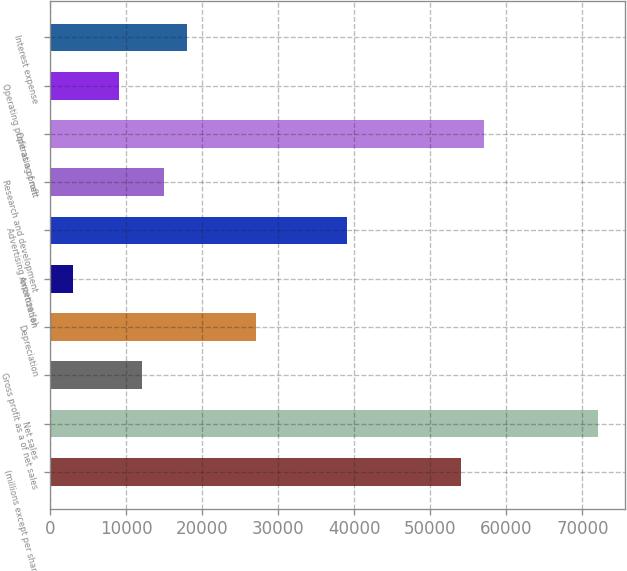Convert chart to OTSL. <chart><loc_0><loc_0><loc_500><loc_500><bar_chart><fcel>(millions except per share<fcel>Net sales<fcel>Gross profit as a of net sales<fcel>Depreciation<fcel>Amortization<fcel>Advertising expense (a)<fcel>Research and development<fcel>Operating profit<fcel>Operating profit as a of net<fcel>Interest expense<nl><fcel>53998.6<fcel>71997.5<fcel>12001.1<fcel>27000.2<fcel>3001.62<fcel>38999.5<fcel>15000.9<fcel>56998.4<fcel>9001.26<fcel>18000.7<nl></chart> 